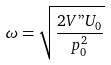Convert formula to latex. <formula><loc_0><loc_0><loc_500><loc_500>\omega = \sqrt { \frac { 2 V " U _ { 0 } } { p _ { 0 } ^ { 2 } } }</formula> 